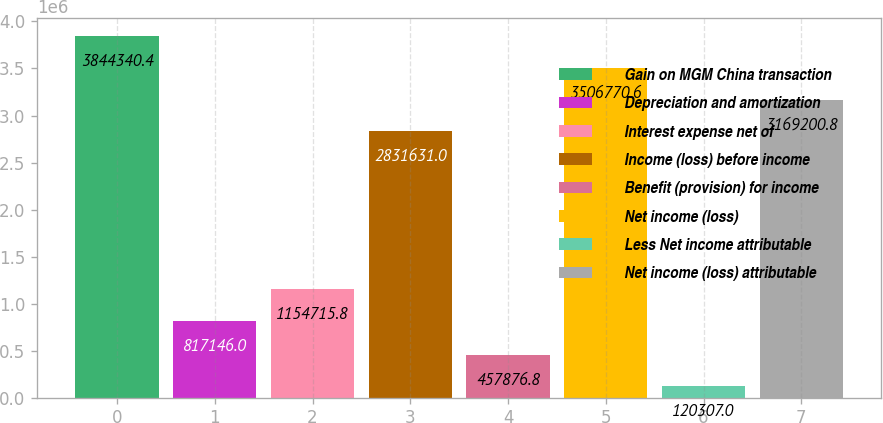Convert chart. <chart><loc_0><loc_0><loc_500><loc_500><bar_chart><fcel>Gain on MGM China transaction<fcel>Depreciation and amortization<fcel>Interest expense net of<fcel>Income (loss) before income<fcel>Benefit (provision) for income<fcel>Net income (loss)<fcel>Less Net income attributable<fcel>Net income (loss) attributable<nl><fcel>3.84434e+06<fcel>817146<fcel>1.15472e+06<fcel>2.83163e+06<fcel>457877<fcel>3.50677e+06<fcel>120307<fcel>3.1692e+06<nl></chart> 